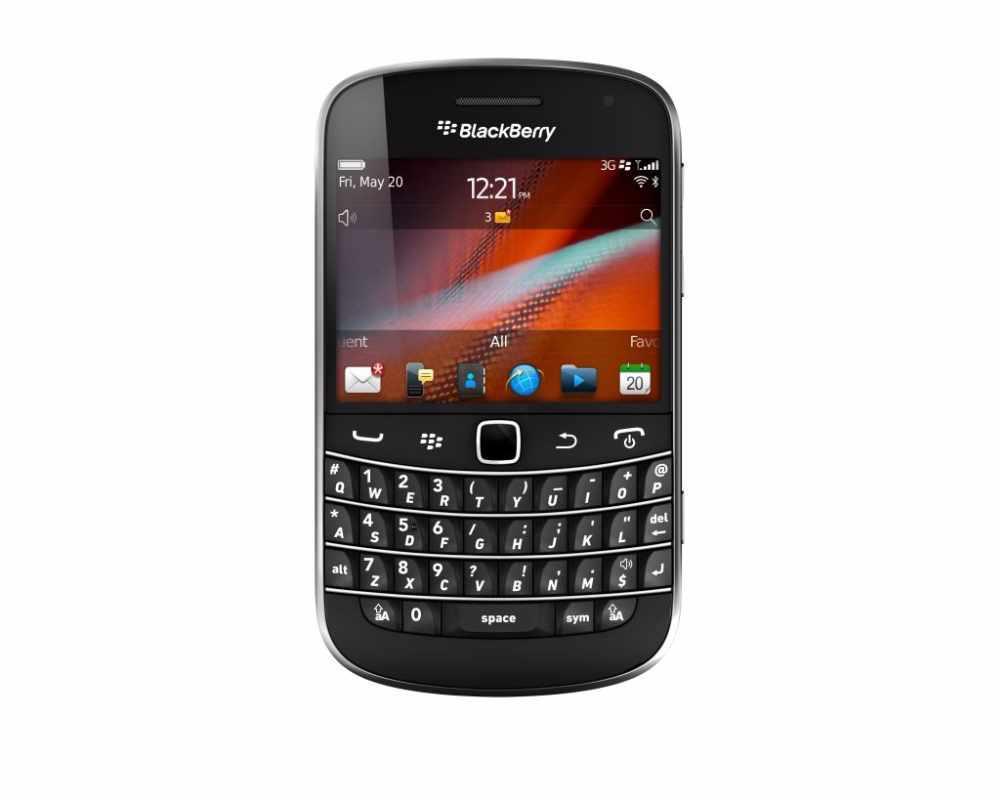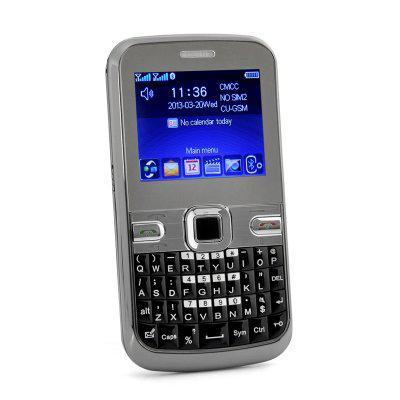The first image is the image on the left, the second image is the image on the right. Examine the images to the left and right. Is the description "Both phones display the same time." accurate? Answer yes or no. No. The first image is the image on the left, the second image is the image on the right. Given the left and right images, does the statement "There are a number of stars to the bottom right of one of the phones." hold true? Answer yes or no. No. 